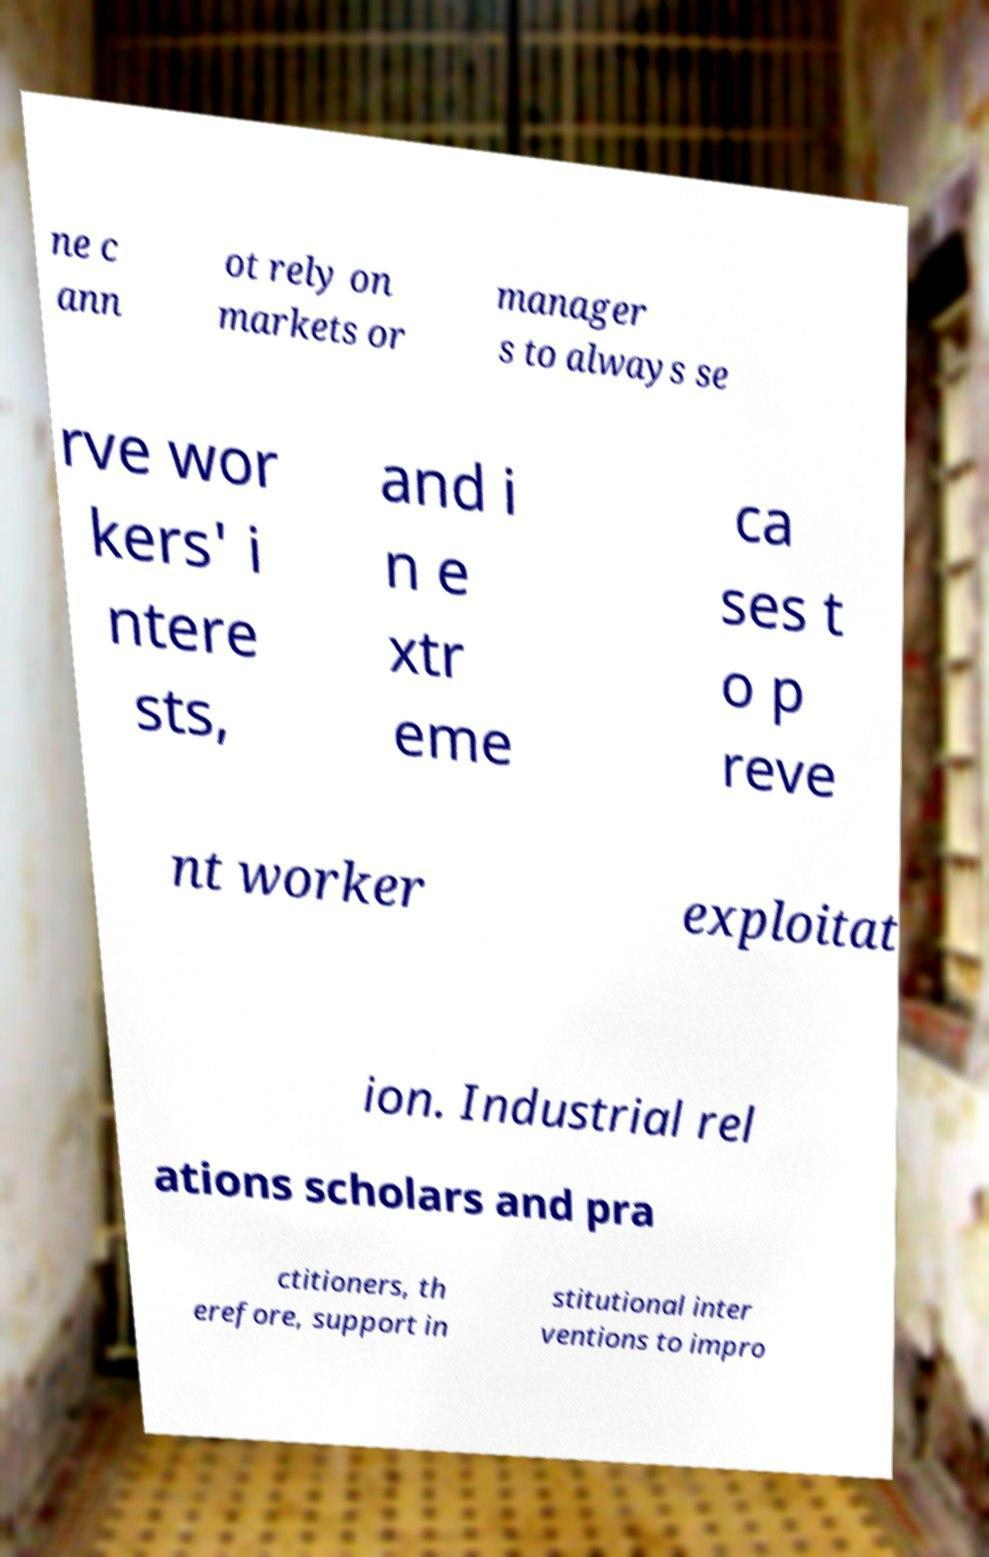Can you accurately transcribe the text from the provided image for me? ne c ann ot rely on markets or manager s to always se rve wor kers' i ntere sts, and i n e xtr eme ca ses t o p reve nt worker exploitat ion. Industrial rel ations scholars and pra ctitioners, th erefore, support in stitutional inter ventions to impro 